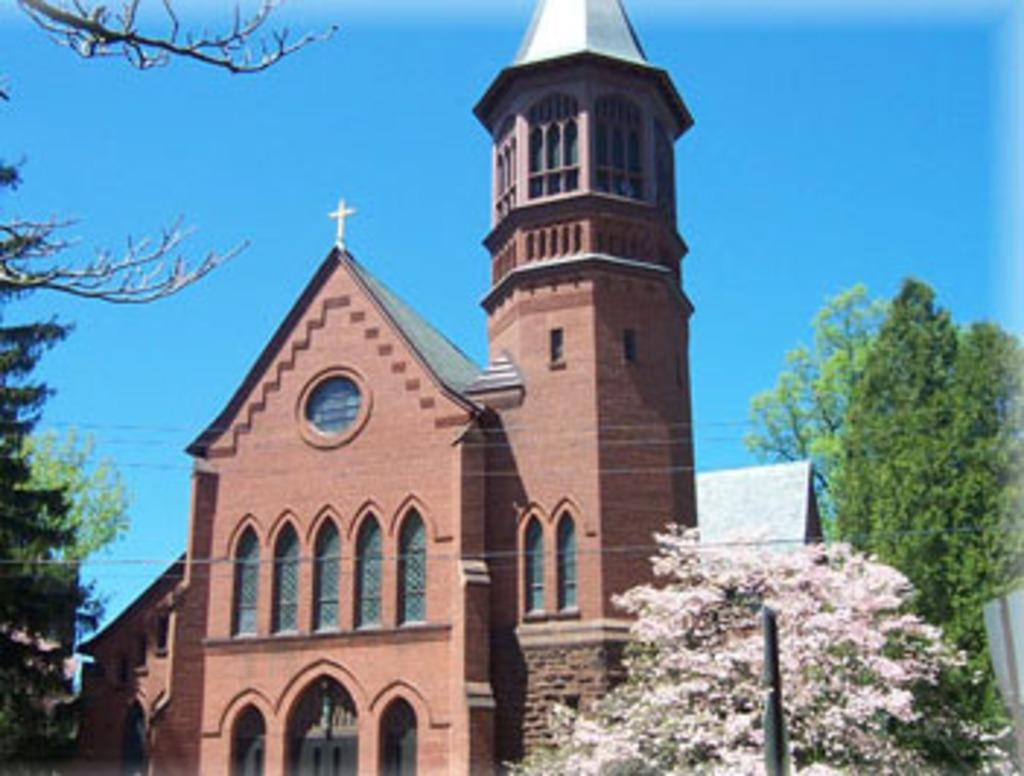What type of building is in the picture? There is a church in the picture. What can be seen on the sides of the picture? There are trees on both the right and left sides of the picture. What is visible at the top of the picture? The sky is visible at the top of the picture. What type of fear can be seen on the faces of the churchgoers in the image? There are no people or faces visible in the image, so it is not possible to determine if they are experiencing fear. 